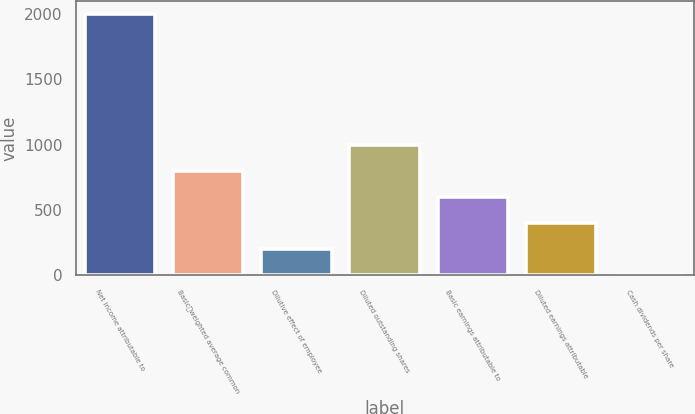<chart> <loc_0><loc_0><loc_500><loc_500><bar_chart><fcel>Net income attributable to<fcel>Basicweighted average common<fcel>Dilutive effect of employee<fcel>Diluted outstanding shares<fcel>Basic earnings attributable to<fcel>Diluted earnings attributable<fcel>Cash dividends per share<nl><fcel>1994<fcel>797.88<fcel>199.81<fcel>997.24<fcel>598.53<fcel>399.17<fcel>0.45<nl></chart> 